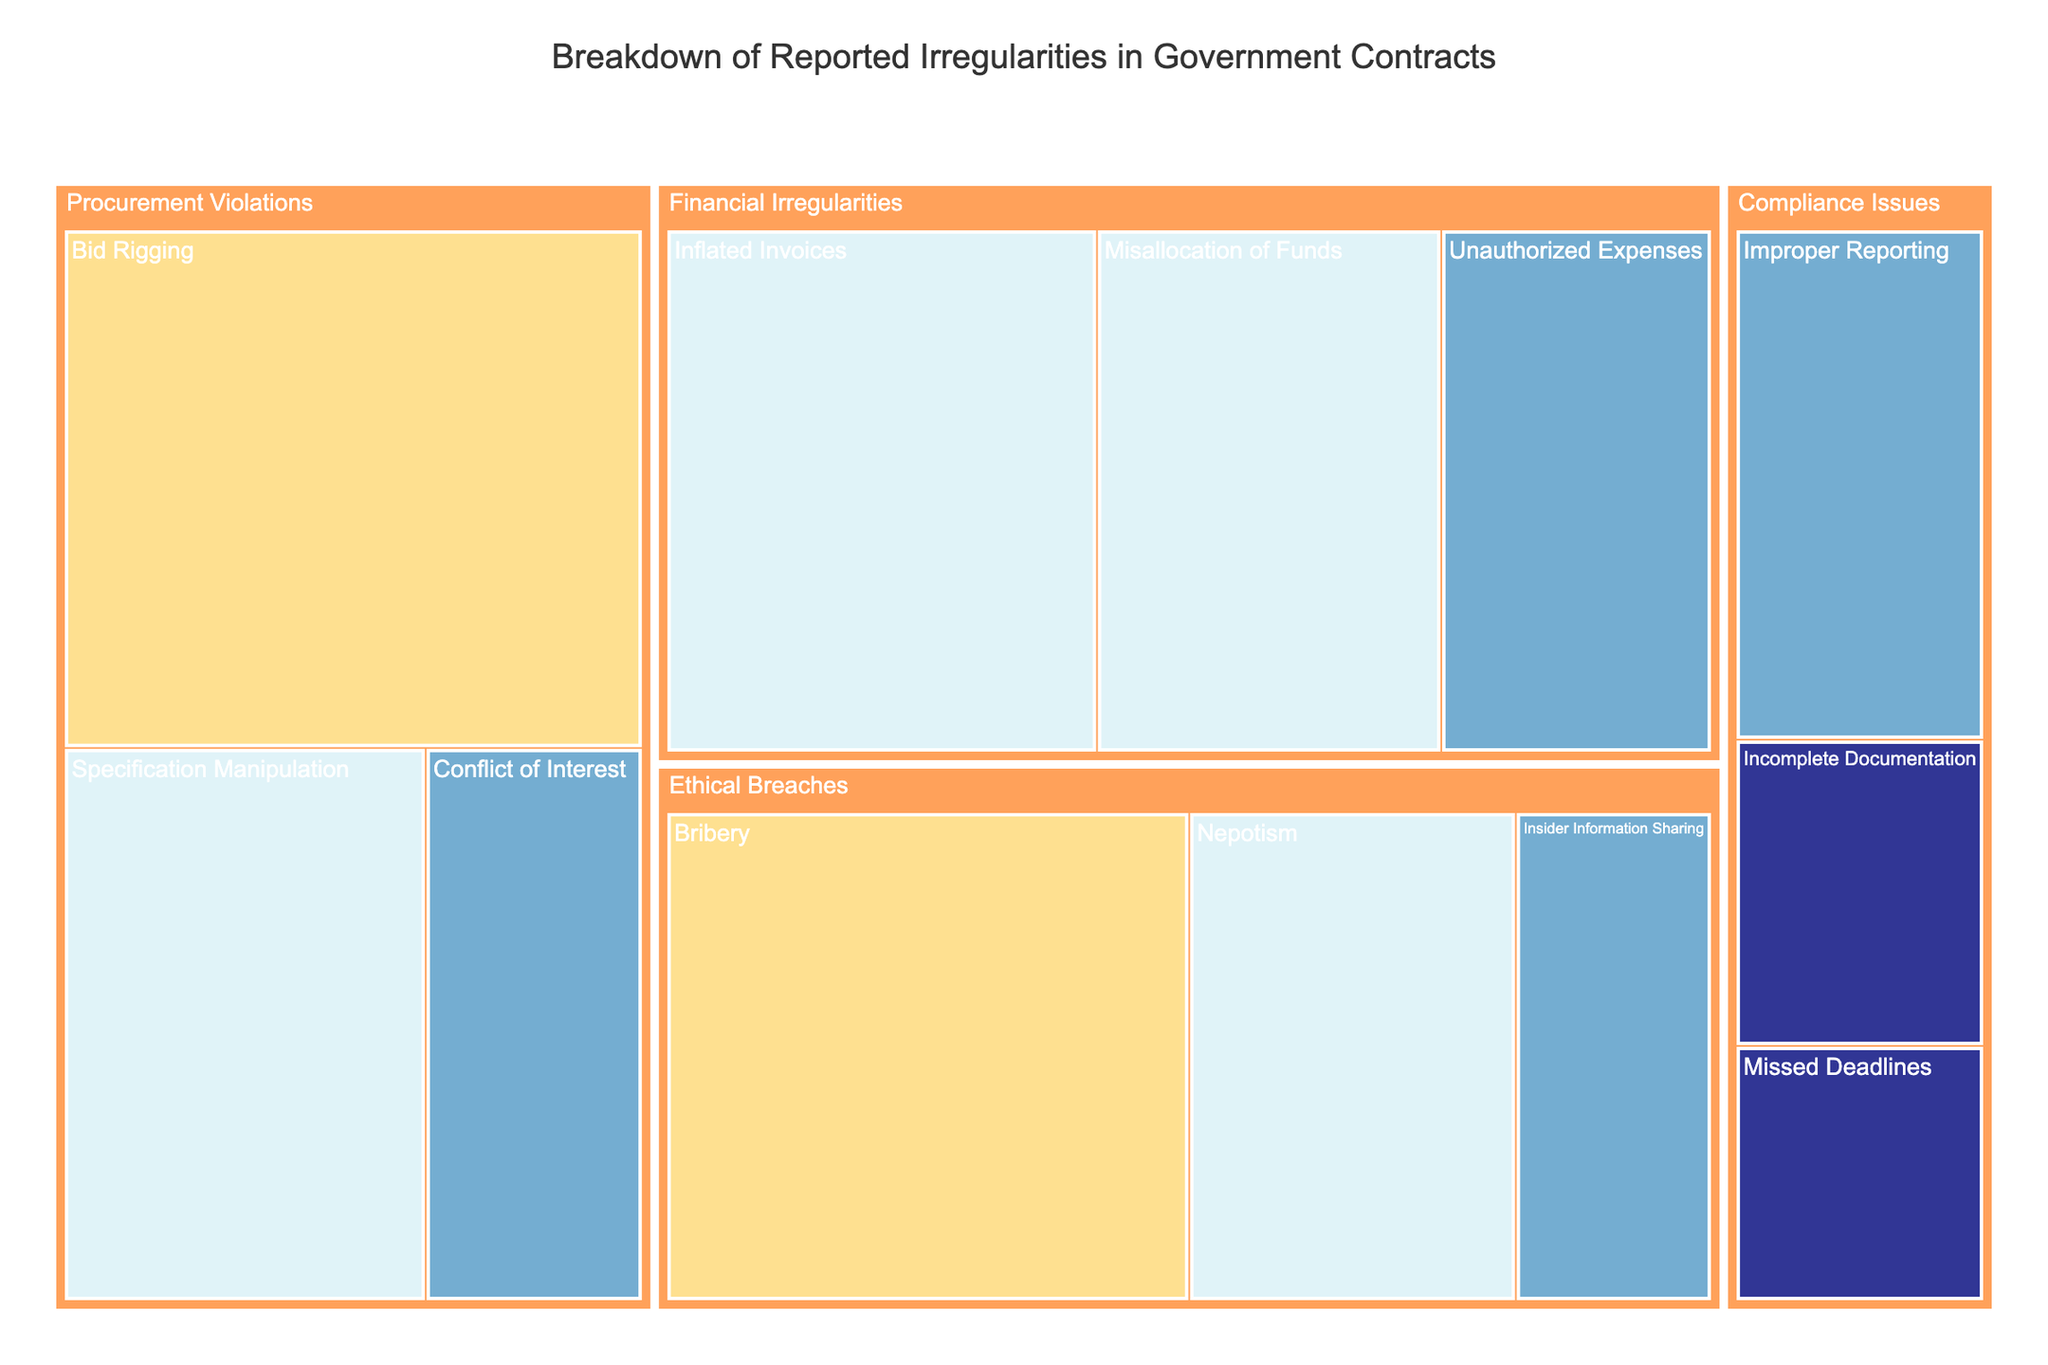What is the title of the treemap? The title of any chart is typically displayed at the top and provides a summary of the content shown. In this case, the title indicates the subject matter of the treemap: Breakdown of Reported Irregularities in Government Contracts.
Answer: Breakdown of Reported Irregularities in Government Contracts Which category has the highest reported irregularity? To find the category with the highest reported irregularity, look for the category with the largest area on the treemap. In the given data, Procurement Violations has the highest single value (45 for Bid Rigging).
Answer: Procurement Violations What is the severity of the most frequent irregularity? By analyzing the treemap, identify the irregularity with the highest value and note its severity. The most frequent irregularity is Bid Rigging with a critical severity.
Answer: Critical How many types of financial irregularities are shown? The treemap organizes data hierarchically, look for the types under the Financial Irregularities category. There are three types listed: Inflated Invoices, Unauthorized Expenses, and Misallocation of Funds.
Answer: Three What is the combined value of high severity irregularities in the Ethical Breaches category? Identify all high severity irregularities under the Ethical Breaches category and sum their values. Nepotism has a high severity with a value of 25.
Answer: 25 What is the difference in value between the highest and lowest severity irregularities? Identify the highest value (Bid Rigging with 45) and the lowest value (Missed Deadlines with 10), then calculate the difference. The difference is 45 - 10.
Answer: 35 Which category has the lowest severity for reported irregularities? Locate the categories with low severity irregularities. Compliance Issues has two types with low severity (Incomplete Documentation and Missed Deadlines).
Answer: Compliance Issues How many irregularities are reported under Compliance Issues? Count the types listed under the Compliance Issues category on the treemap. The types are Incomplete Documentation, Missed Deadlines, and Improper Reporting.
Answer: Three Which type under Financial Irregularities has the highest reported value? Under the Financial Irregularities category, compare the values of each type. Inflated Invoices has the highest value of 35.
Answer: Inflated Invoices What is the relationship between Ethical Breaches and Financial Irregularities based on severity? Compare the severities of types under both categories. Ethical Breaches has a critical severity (Bribery with 40) while Financial Irregularities does not, showing a higher maximum severity in Ethical Breaches.
Answer: Ethical Breaches has higher maximum severity 